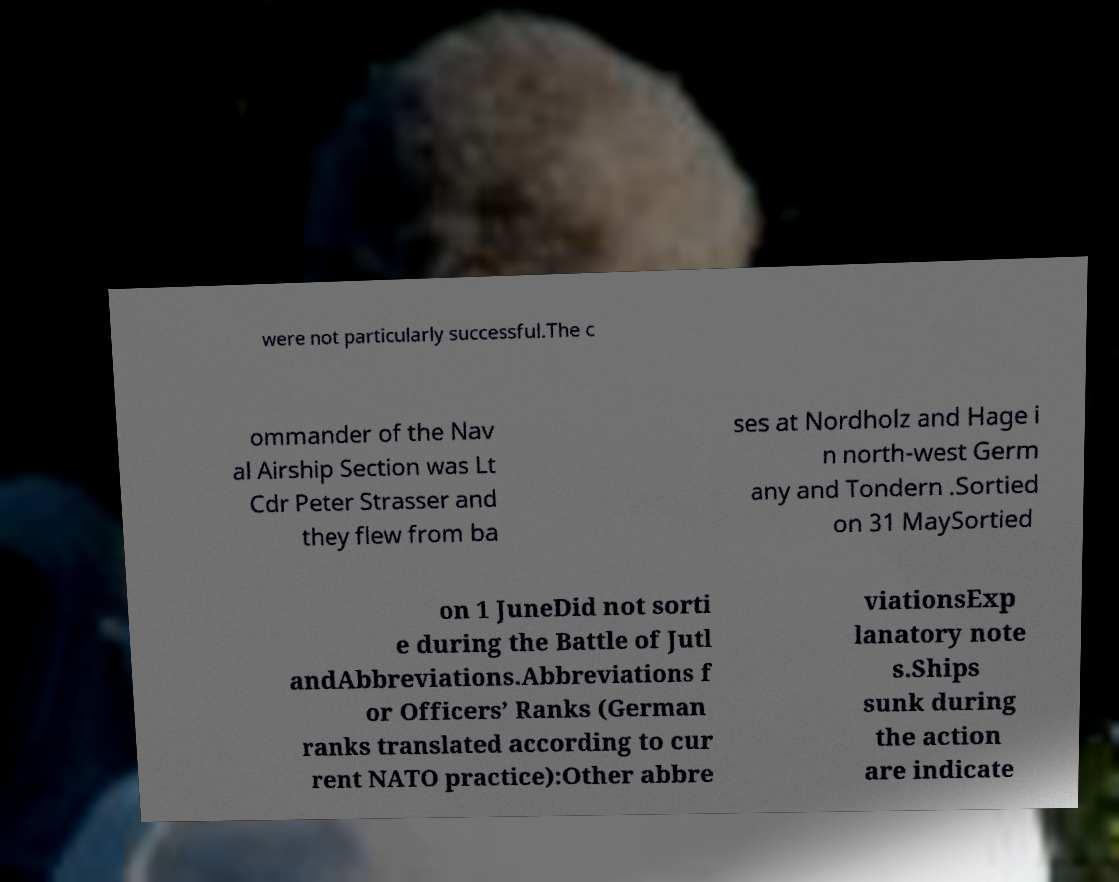Please read and relay the text visible in this image. What does it say? were not particularly successful.The c ommander of the Nav al Airship Section was Lt Cdr Peter Strasser and they flew from ba ses at Nordholz and Hage i n north-west Germ any and Tondern .Sortied on 31 MaySortied on 1 JuneDid not sorti e during the Battle of Jutl andAbbreviations.Abbreviations f or Officers’ Ranks (German ranks translated according to cur rent NATO practice):Other abbre viationsExp lanatory note s.Ships sunk during the action are indicate 